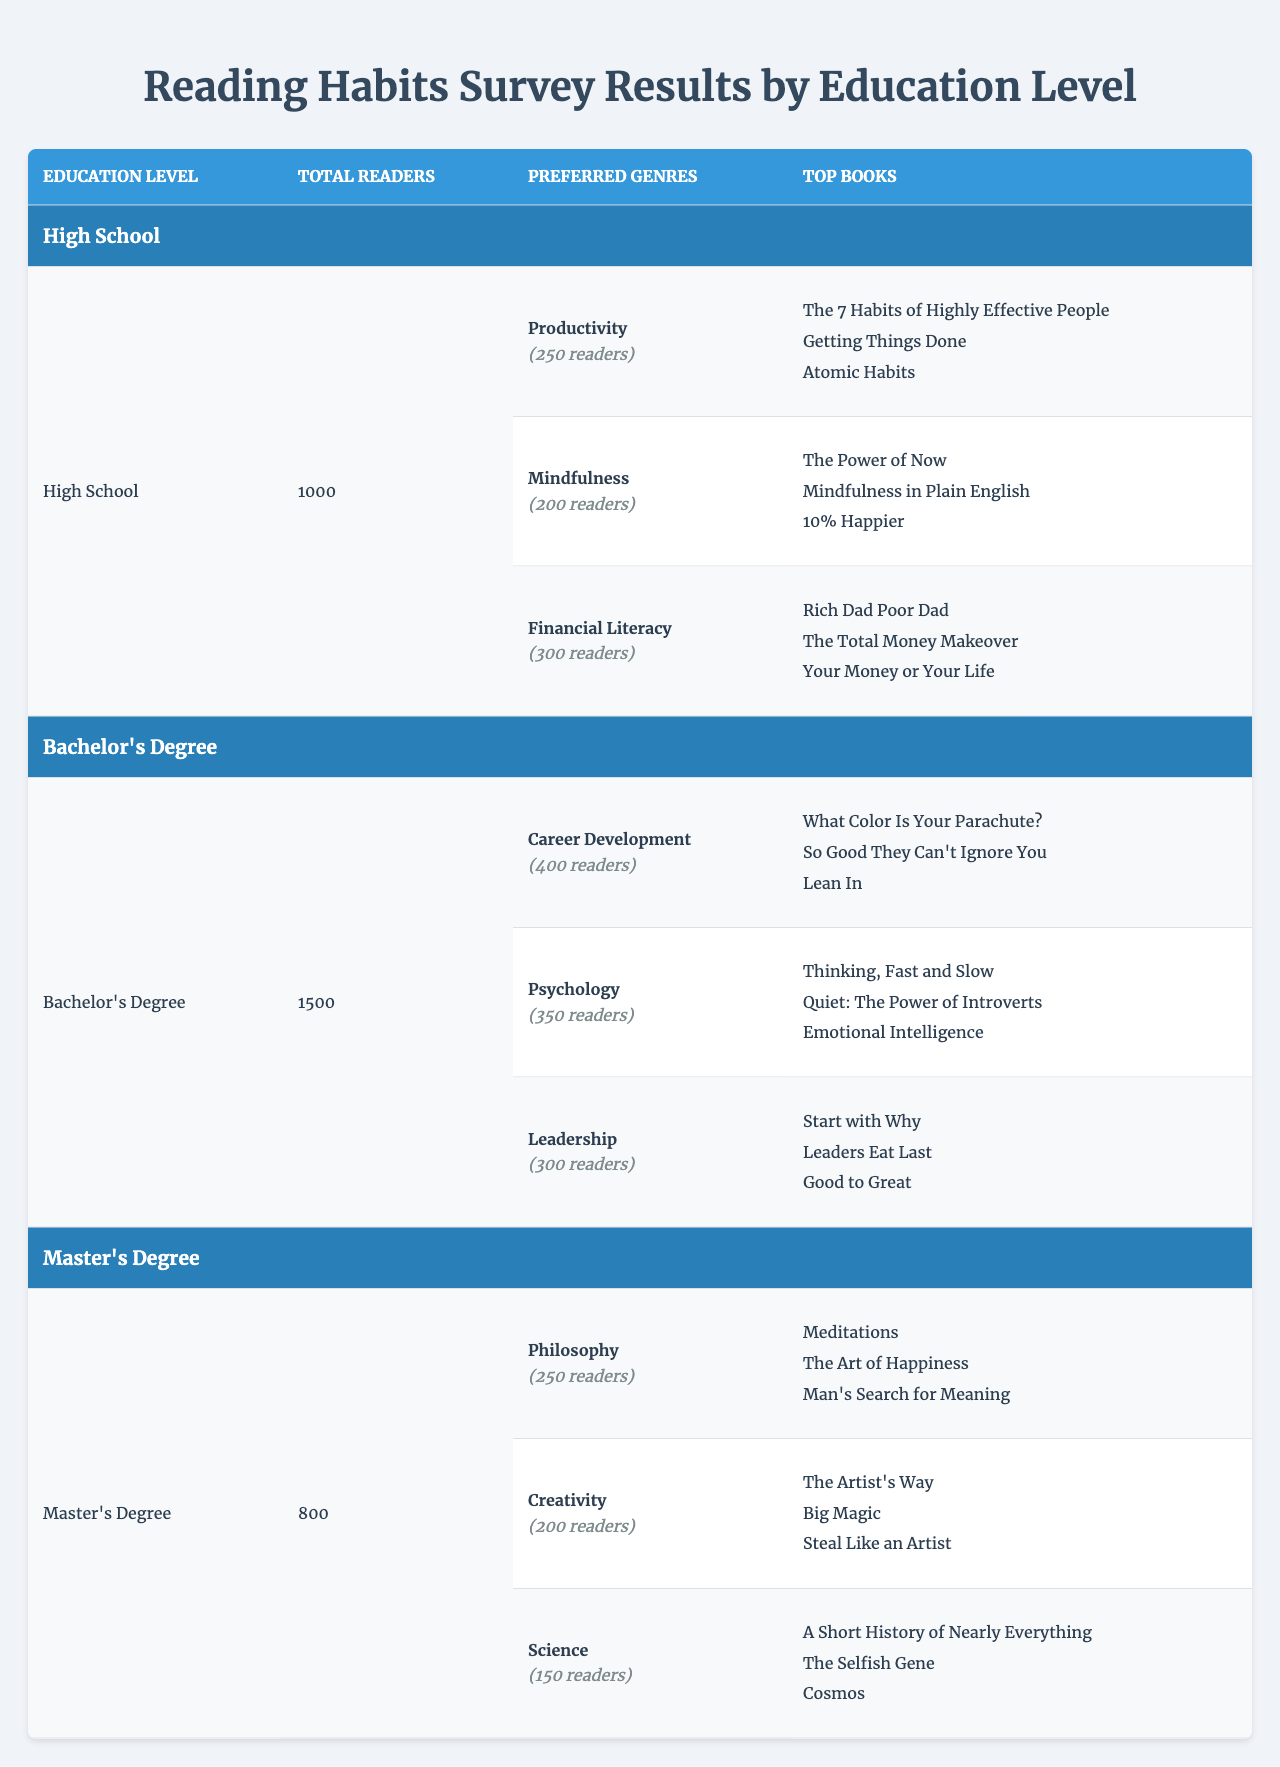What is the total number of readers with a Bachelor's Degree? According to the table, the total number of readers for those with a Bachelor's Degree is explicitly stated as 1500.
Answer: 1500 Which preferred genre has the highest number of readers among High School graduates? The genres preferred by High School graduates are listed with their respective readers: Productivity (250), Mindfulness (200), and Financial Literacy (300). Financial Literacy has the highest count with 300 readers.
Answer: Financial Literacy How many readers prefer Psychology among Bachelor's degree holders? In the table, it indicates that the Psychology genre has 350 readers for those with a Bachelor's Degree.
Answer: 350 What is the difference in the total number of readers between High School and Master's Degree graduates? The total number of readers for High School graduates is 1000 and for Master's Degree graduates, it is 800. The difference is calculated as 1000 - 800 = 200.
Answer: 200 Is the number of readers interested in Creativity among Master's Degree holders greater than those interested in Mindfulness among High School graduates? The number of readers interested in Creativity is 200 (Master's Degree), while for Mindfulness it is 200 (High School). Since both values are equal, the answer is no.
Answer: No Which genre has the fewest readers among Master's Degree holders? The genres listed for Master's Degree holders are Philosophy (250), Creativity (200), and Science (150). Science has the fewest readers with 150.
Answer: Science Calculate the total number of readers across all education levels. The total number of readers can be summed as follows: High School (1000) + Bachelor's Degree (1500) + Master's Degree (800) = 3300.
Answer: 3300 What is the average number of readers per preferred genre among Bachelor's Degree holders? There are three preferred genres for Bachelor's Degree holders: Career Development (400), Psychology (350), and Leadership (300). The total for these genres is 400 + 350 + 300 = 1050. Dividing this by the 3 genres gives an average of 1050 / 3 = 350.
Answer: 350 Do more than 400 readers prefer Productivity among High School graduates? The number of readers for Productivity among High School graduates is 250 which is less than 400. Thus the answer is no.
Answer: No Which education level has the highest preference for Financial Literacy? Only High School graduates have a preference for Financial Literacy, with 300 readers. Other education levels do not list Financial Literacy as a preferred genre, making High School the only one.
Answer: High School 